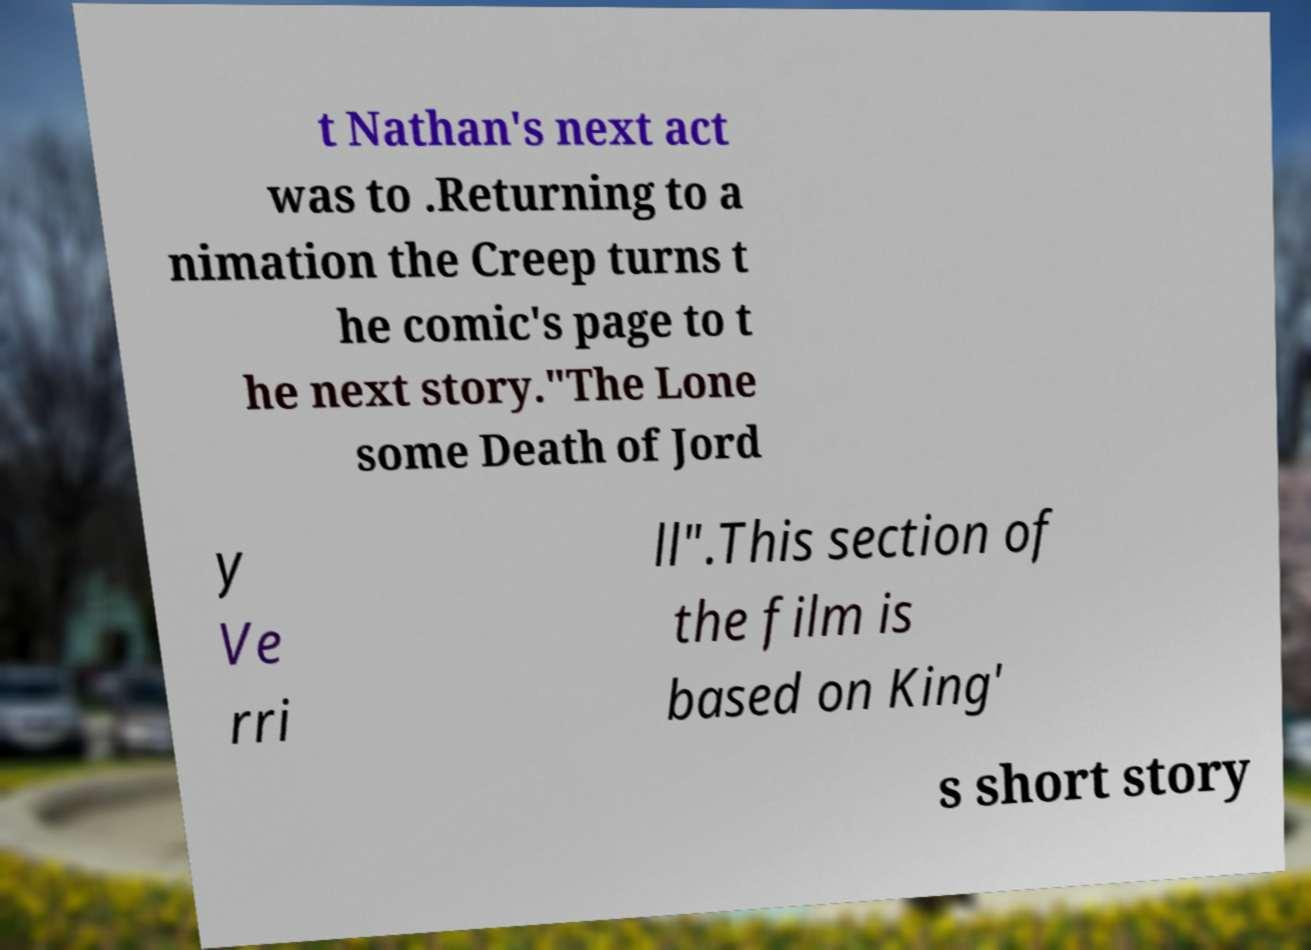Could you extract and type out the text from this image? t Nathan's next act was to .Returning to a nimation the Creep turns t he comic's page to t he next story."The Lone some Death of Jord y Ve rri ll".This section of the film is based on King' s short story 